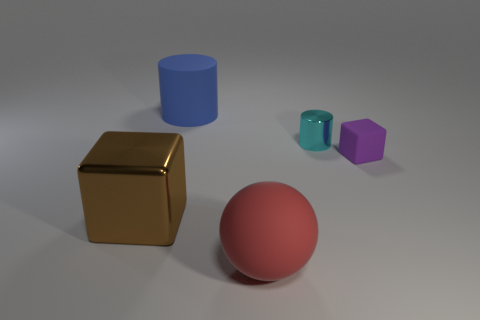Do the colors of these objects tell us anything about their three-dimensional form? The colors enhance the three-dimensional appearance, with the variations in shading providing cues about their curvature and depth. The gold and blue cylindrical objects show vertical gradients, the red sphere shows a radial gradient, and the purple prism has distinct faces with different shades indicating its geometric form. 